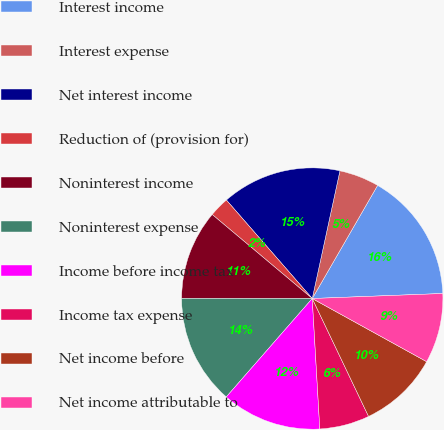Convert chart. <chart><loc_0><loc_0><loc_500><loc_500><pie_chart><fcel>Interest income<fcel>Interest expense<fcel>Net interest income<fcel>Reduction of (provision for)<fcel>Noninterest income<fcel>Noninterest expense<fcel>Income before income tax<fcel>Income tax expense<fcel>Net income before<fcel>Net income attributable to<nl><fcel>16.05%<fcel>4.94%<fcel>14.81%<fcel>2.47%<fcel>11.11%<fcel>13.58%<fcel>12.35%<fcel>6.17%<fcel>9.88%<fcel>8.64%<nl></chart> 